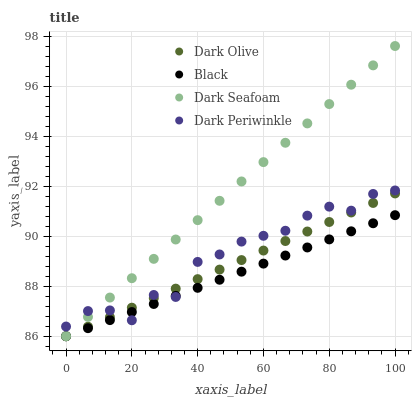Does Black have the minimum area under the curve?
Answer yes or no. Yes. Does Dark Seafoam have the maximum area under the curve?
Answer yes or no. Yes. Does Dark Olive have the minimum area under the curve?
Answer yes or no. No. Does Dark Olive have the maximum area under the curve?
Answer yes or no. No. Is Dark Seafoam the smoothest?
Answer yes or no. Yes. Is Dark Periwinkle the roughest?
Answer yes or no. Yes. Is Dark Olive the smoothest?
Answer yes or no. No. Is Dark Olive the roughest?
Answer yes or no. No. Does Dark Seafoam have the lowest value?
Answer yes or no. Yes. Does Dark Periwinkle have the lowest value?
Answer yes or no. No. Does Dark Seafoam have the highest value?
Answer yes or no. Yes. Does Dark Olive have the highest value?
Answer yes or no. No. Does Black intersect Dark Periwinkle?
Answer yes or no. Yes. Is Black less than Dark Periwinkle?
Answer yes or no. No. Is Black greater than Dark Periwinkle?
Answer yes or no. No. 